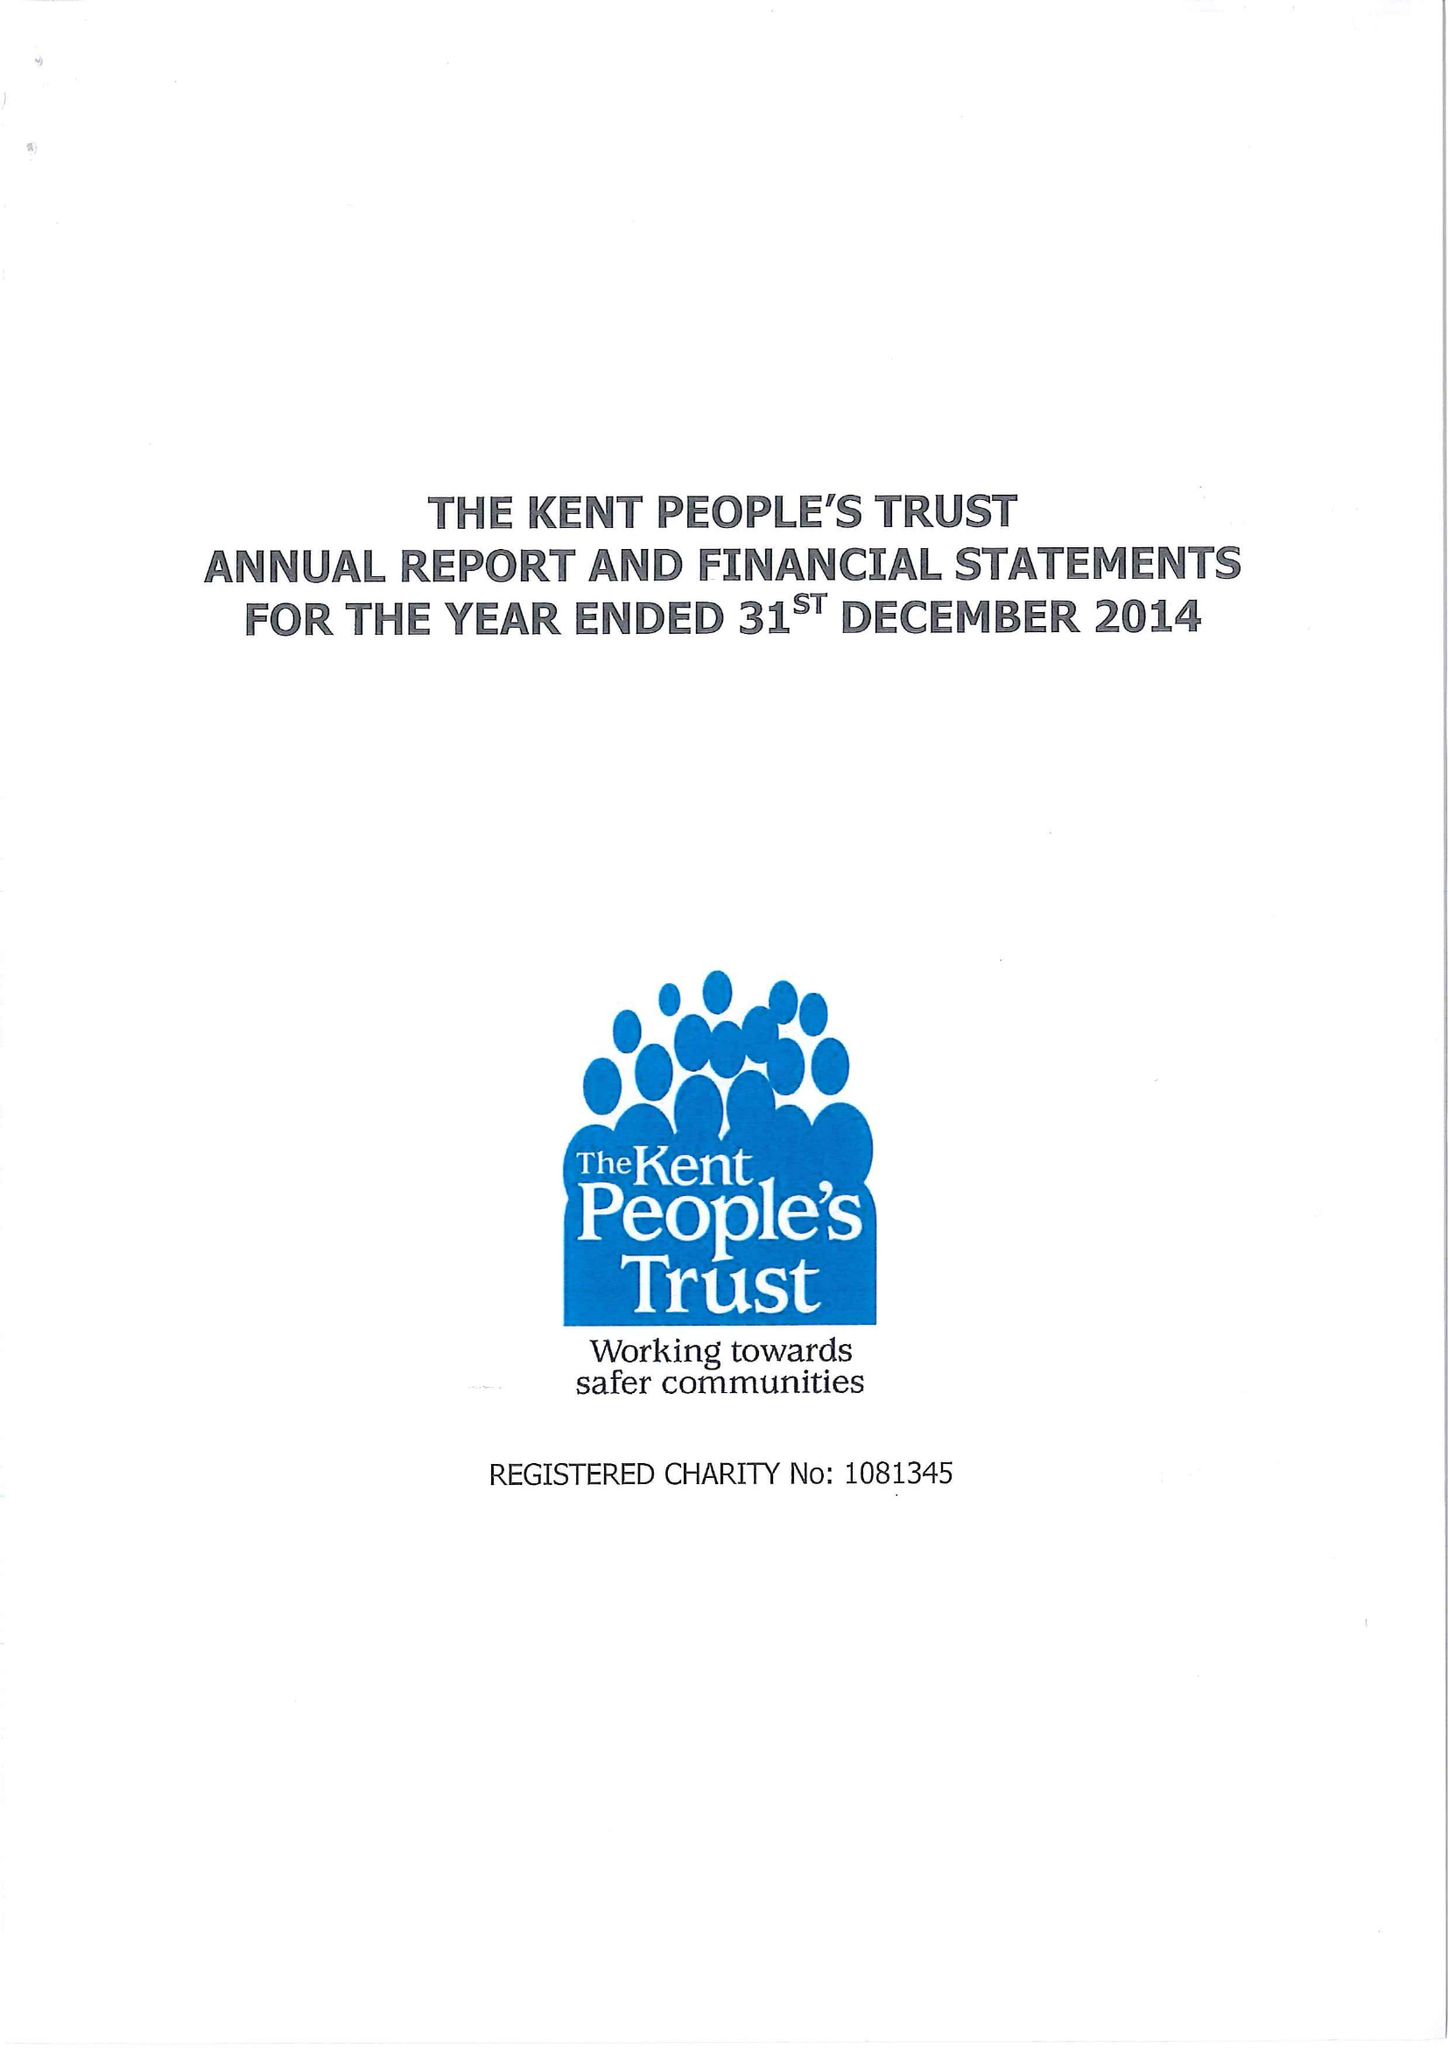What is the value for the address__post_town?
Answer the question using a single word or phrase. MAIDSTONE 